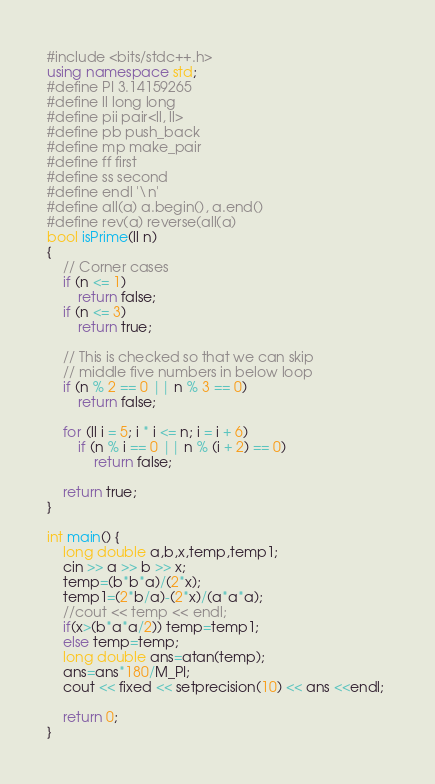Convert code to text. <code><loc_0><loc_0><loc_500><loc_500><_C++_>#include <bits/stdc++.h>
using namespace std;
#define PI 3.14159265
#define ll long long
#define pii pair<ll, ll>
#define pb push_back
#define mp make_pair
#define ff first
#define ss second
#define endl '\n'
#define all(a) a.begin(), a.end()
#define rev(a) reverse(all(a)
bool isPrime(ll n) 
{ 
    // Corner cases 
    if (n <= 1) 
        return false; 
    if (n <= 3) 
        return true; 
  
    // This is checked so that we can skip 
    // middle five numbers in below loop 
    if (n % 2 == 0 || n % 3 == 0) 
        return false; 
  
    for (ll i = 5; i * i <= n; i = i + 6) 
        if (n % i == 0 || n % (i + 2) == 0) 
            return false; 
  
    return true; 
} 
   
int main() {
    long double a,b,x,temp,temp1;
    cin >> a >> b >> x;
    temp=(b*b*a)/(2*x);
    temp1=(2*b/a)-(2*x)/(a*a*a);
    //cout << temp << endl;
    if(x>(b*a*a/2)) temp=temp1;
    else temp=temp;
    long double ans=atan(temp);
    ans=ans*180/M_PI;
    cout << fixed << setprecision(10) << ans <<endl; 
   
	return 0;
}</code> 